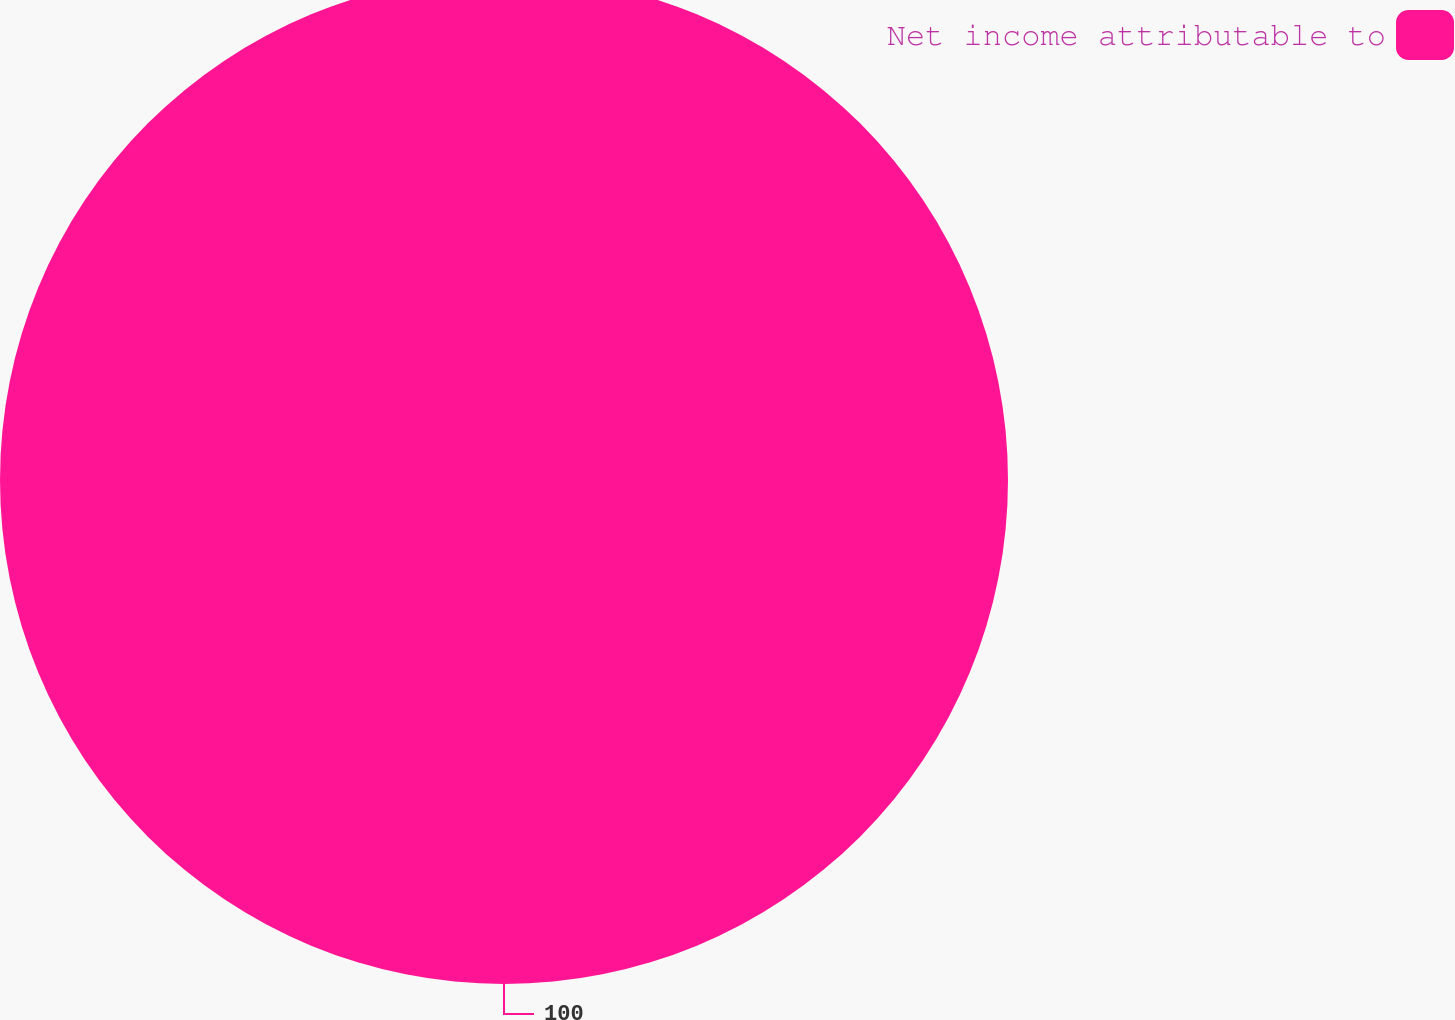Convert chart. <chart><loc_0><loc_0><loc_500><loc_500><pie_chart><fcel>Net income attributable to<nl><fcel>100.0%<nl></chart> 